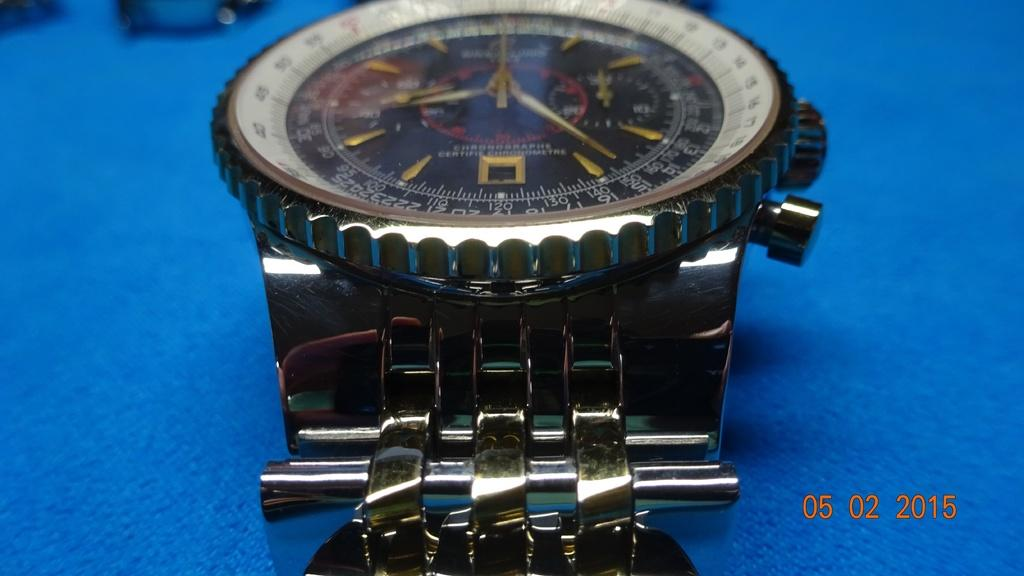<image>
Render a clear and concise summary of the photo. A wrist watch reading 8:25 sits on a table 